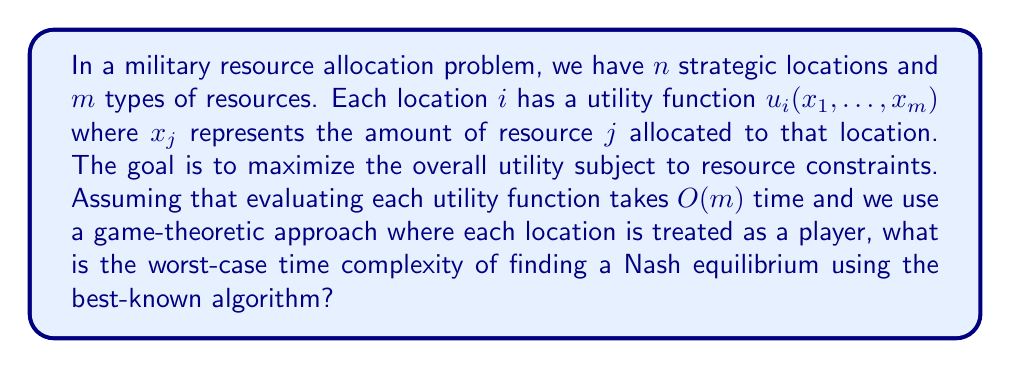Show me your answer to this math problem. To analyze the computational complexity of this problem, we need to consider the following steps:

1. First, we recognize that this problem can be modeled as a strategic-form game with $n$ players (locations) and $m$ strategies (resource allocation options) for each player.

2. Finding a Nash equilibrium in a strategic-form game is known to be PPAD-complete (Polynomial Parity Arguments on Directed graphs). The best-known algorithm for finding a Nash equilibrium in such games is the Lemke-Howson algorithm.

3. The worst-case time complexity of the Lemke-Howson algorithm is exponential in the number of players and strategies. Specifically, it is $O(2^{n+m})$.

4. However, in our case, we also need to consider the time complexity of evaluating the utility functions. For each step of the algorithm, we may need to evaluate all utility functions for all players.

5. Evaluating a single utility function takes $O(m)$ time, and we have $n$ players. So, the total time for utility function evaluations in each step is $O(nm)$.

6. Combining the complexity of the Lemke-Howson algorithm with the utility function evaluations, we get:

   $$O(2^{n+m} \cdot nm)$$

7. This represents the worst-case time complexity of finding a Nash equilibrium in our military resource allocation problem using a game-theoretic approach.

It's worth noting that this worst-case complexity assumes that the algorithm explores all possible combinations, which may not always be necessary in practice. However, as a skeptical general concerned with potential hidden agendas, it's prudent to consider the worst-case scenario.
Answer: The worst-case time complexity is $O(2^{n+m} \cdot nm)$, where $n$ is the number of strategic locations and $m$ is the number of resource types. 